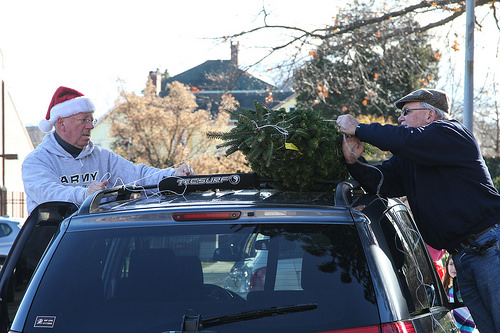<image>
Is there a tree to the left of the man? Yes. From this viewpoint, the tree is positioned to the left side relative to the man. 